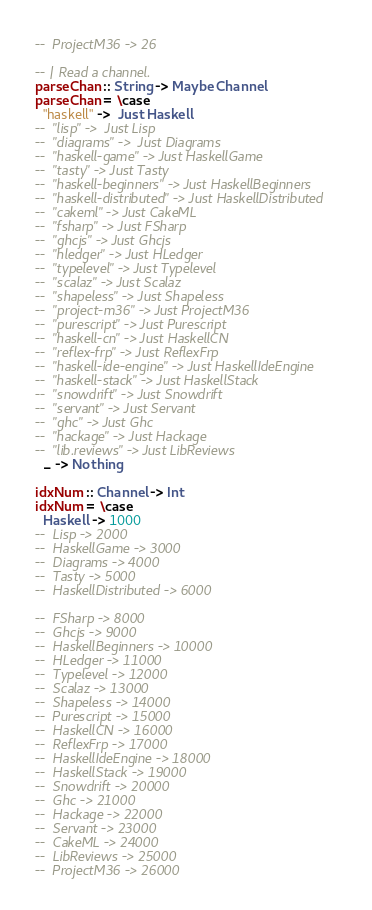Convert code to text. <code><loc_0><loc_0><loc_500><loc_500><_Haskell_>--  ProjectM36 -> 26

-- | Read a channel.
parseChan :: String -> Maybe Channel
parseChan = \case
  "haskell" ->  Just Haskell
--  "lisp" ->  Just Lisp
--  "diagrams" ->  Just Diagrams
--  "haskell-game" -> Just HaskellGame
--  "tasty" -> Just Tasty
--  "haskell-beginners" -> Just HaskellBeginners
--  "haskell-distributed" -> Just HaskellDistributed
--  "cakeml" -> Just CakeML
--  "fsharp" -> Just FSharp
--  "ghcjs" -> Just Ghcjs
--  "hledger" -> Just HLedger
--  "typelevel" -> Just Typelevel
--  "scalaz" -> Just Scalaz
--  "shapeless" -> Just Shapeless
--  "project-m36" -> Just ProjectM36
--  "purescript" -> Just Purescript
--  "haskell-cn" -> Just HaskellCN
--  "reflex-frp" -> Just ReflexFrp
--  "haskell-ide-engine" -> Just HaskellIdeEngine
--  "haskell-stack" -> Just HaskellStack
--  "snowdrift" -> Just Snowdrift
--  "servant" -> Just Servant
--  "ghc" -> Just Ghc
--  "hackage" -> Just Hackage
--  "lib.reviews" -> Just LibReviews
  _ -> Nothing

idxNum :: Channel -> Int
idxNum = \case
  Haskell -> 1000
--  Lisp -> 2000
--  HaskellGame -> 3000
--  Diagrams -> 4000
--  Tasty -> 5000
--  HaskellDistributed -> 6000

--  FSharp -> 8000
--  Ghcjs -> 9000
--  HaskellBeginners -> 10000
--  HLedger -> 11000
--  Typelevel -> 12000
--  Scalaz -> 13000
--  Shapeless -> 14000
--  Purescript -> 15000
--  HaskellCN -> 16000
--  ReflexFrp -> 17000
--  HaskellIdeEngine -> 18000
--  HaskellStack -> 19000
--  Snowdrift -> 20000
--  Ghc -> 21000
--  Hackage -> 22000
--  Servant -> 23000
--  CakeML -> 24000
--  LibReviews -> 25000
--  ProjectM36 -> 26000
</code> 